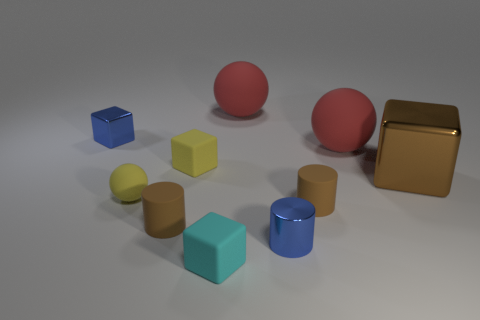Subtract all cubes. How many objects are left? 6 Add 10 tiny green rubber spheres. How many tiny green rubber spheres exist? 10 Subtract 0 red cylinders. How many objects are left? 10 Subtract all tiny spheres. Subtract all small brown cylinders. How many objects are left? 7 Add 8 blue metallic cylinders. How many blue metallic cylinders are left? 9 